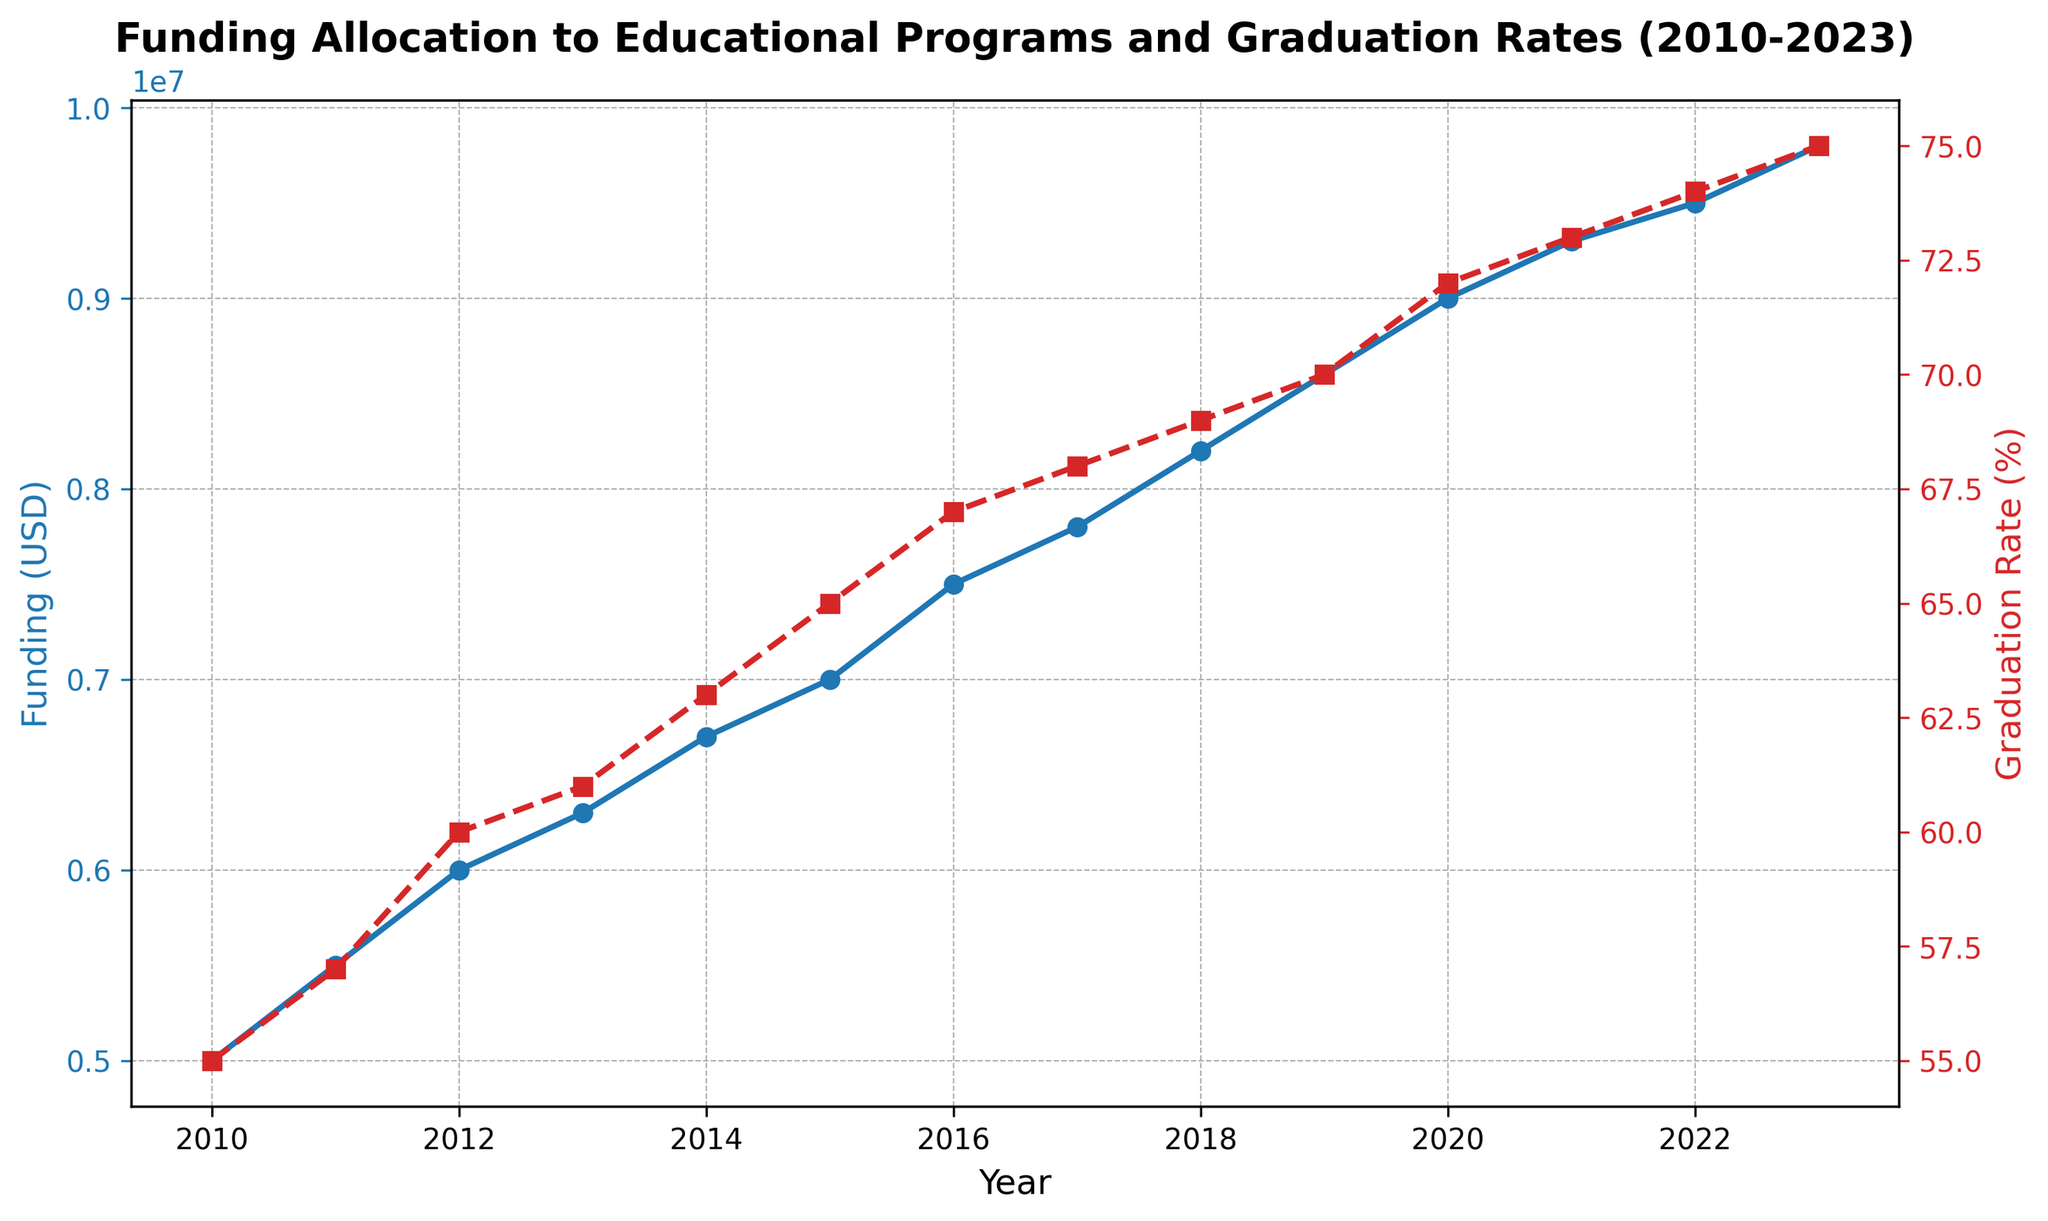How has funding allocation changed from 2010 to 2023? Funding allocation in 2010 was USD 5,000,000. By 2023, it had increased to USD 9,800,000. Subtracting 5,000,000 from 9,800,000 gives an increase of USD 4,800,000 over this period.
Answer: USD 4,800,000 increase What is the overall trend of graduation rates from 2010 to 2023? Graduation rates have steadily increased from 55% in 2010 to 75% in 2023, indicating a positive upward trend over the period.
Answer: Upward trend Was there a year where both funding allocation and graduation rates increased at the same rate? By examining the plot, the rate of increase for both metrics does not exactly match in any given year. However, both metrics show a general concurrent upward trend over the years.
Answer: No exact match found How does the funding allocation in 2020 compare to that in 2015? The funding allocation in 2020 was USD 9,000,000, while in 2015 it was USD 7,000,000. Subtracting these values gives an increase of USD 2,000,000.
Answer: USD 2,000,000 higher In which year did the graduation rate reach 70%? According to the plot, the graduation rate reached 70% in the year 2019.
Answer: 2019 What is the average graduation rate from 2010 to 2015? The graduation rates from 2010 to 2015 were 55%, 57%, 60%, 61%, 63%, and 65%. Adding these rates together gives a total of 361%. Dividing by the number of years (6) gives an average graduation rate of approximately 60.17%.
Answer: Approximately 60.17% Compare the funding allocation growth between 2010-2015 and 2015-2023. From 2010 to 2015, the funding allocation increased from USD 5,000,000 to USD 7,000,000, amounting to an increase of USD 2,000,000. From 2015 to 2023, it increased from USD 7,000,000 to USD 9,800,000, resulting in an increase of USD 2,800,000. Therefore, the growth was greater between 2015 and 2023.
Answer: Greater between 2015-2023 What is the difference in graduation rate between 2013 and 2023? The graduation rate in 2013 was 61%, and in 2023 it was 75%. The difference is 75% - 61% = 14%.
Answer: 14% Describe the visual differences between the funding allocation and graduation rate lines. The funding allocation line is represented by a solid blue line with circular markers, while the graduation rate line is represented by a dashed red line with square markers. Both lines show an upward trend, but the visual styles differentiate them.
Answer: Solid blue line vs. dashed red line Which year showed the highest increase in graduation rate from the previous year? The highest increase in graduation rate from one year to the next is between 2019 (70%) and 2020 (72%) with a difference of 2%. This can be seen clearly by comparing the adjacent years on the chart.
Answer: 2019 to 2020 